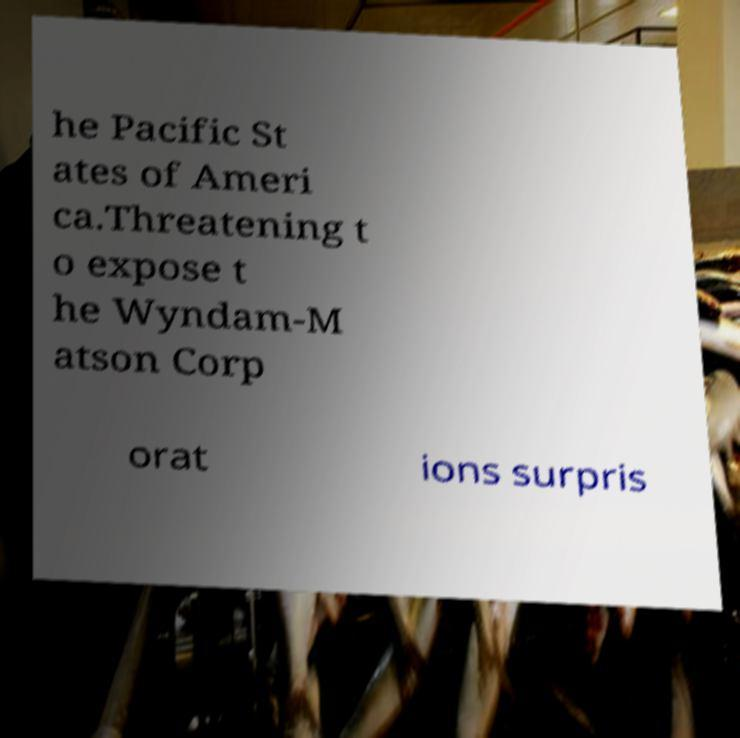Could you extract and type out the text from this image? he Pacific St ates of Ameri ca.Threatening t o expose t he Wyndam-M atson Corp orat ions surpris 